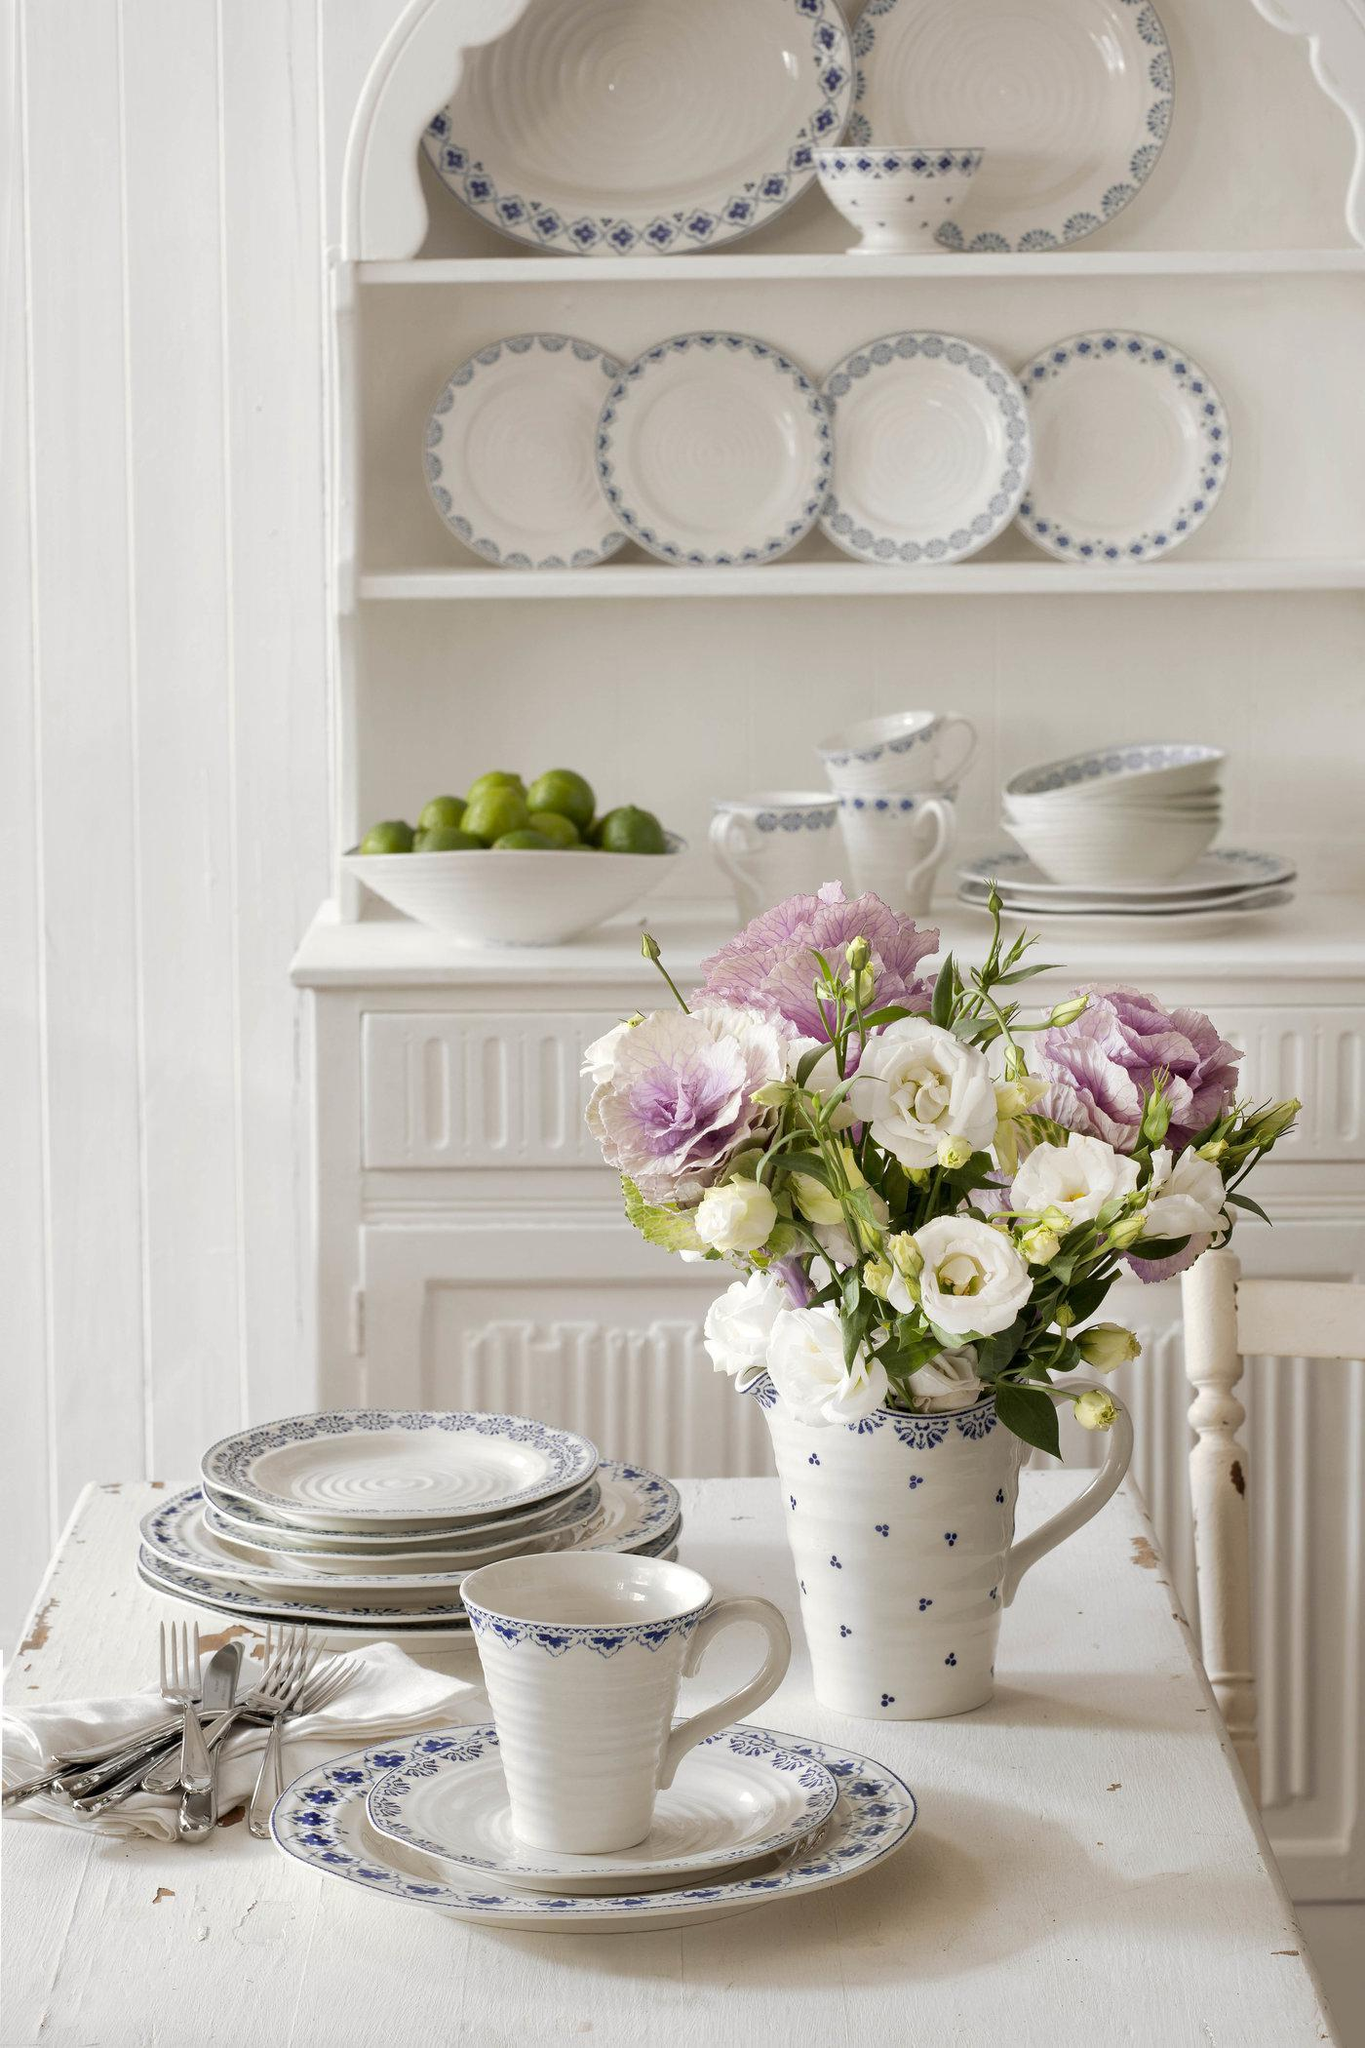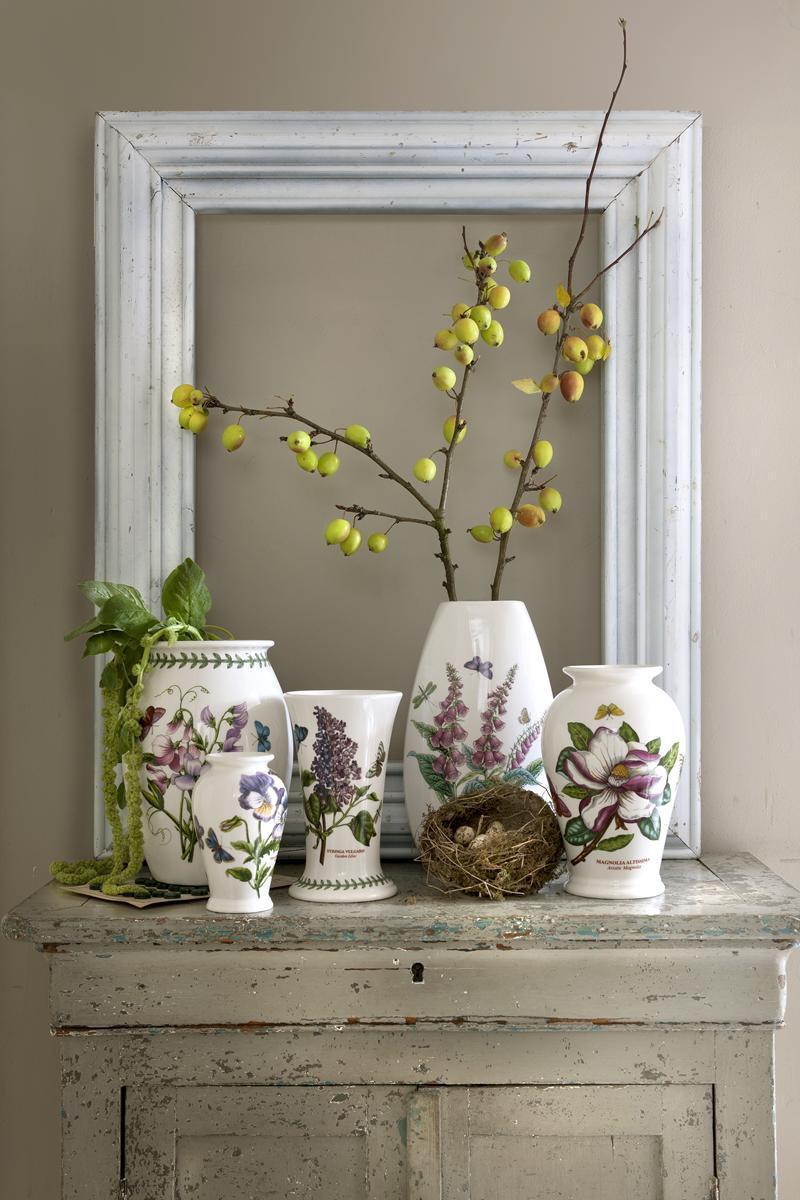The first image is the image on the left, the second image is the image on the right. For the images shown, is this caption "Each image shows exactly one white vase, which does not hold any floral item." true? Answer yes or no. No. 